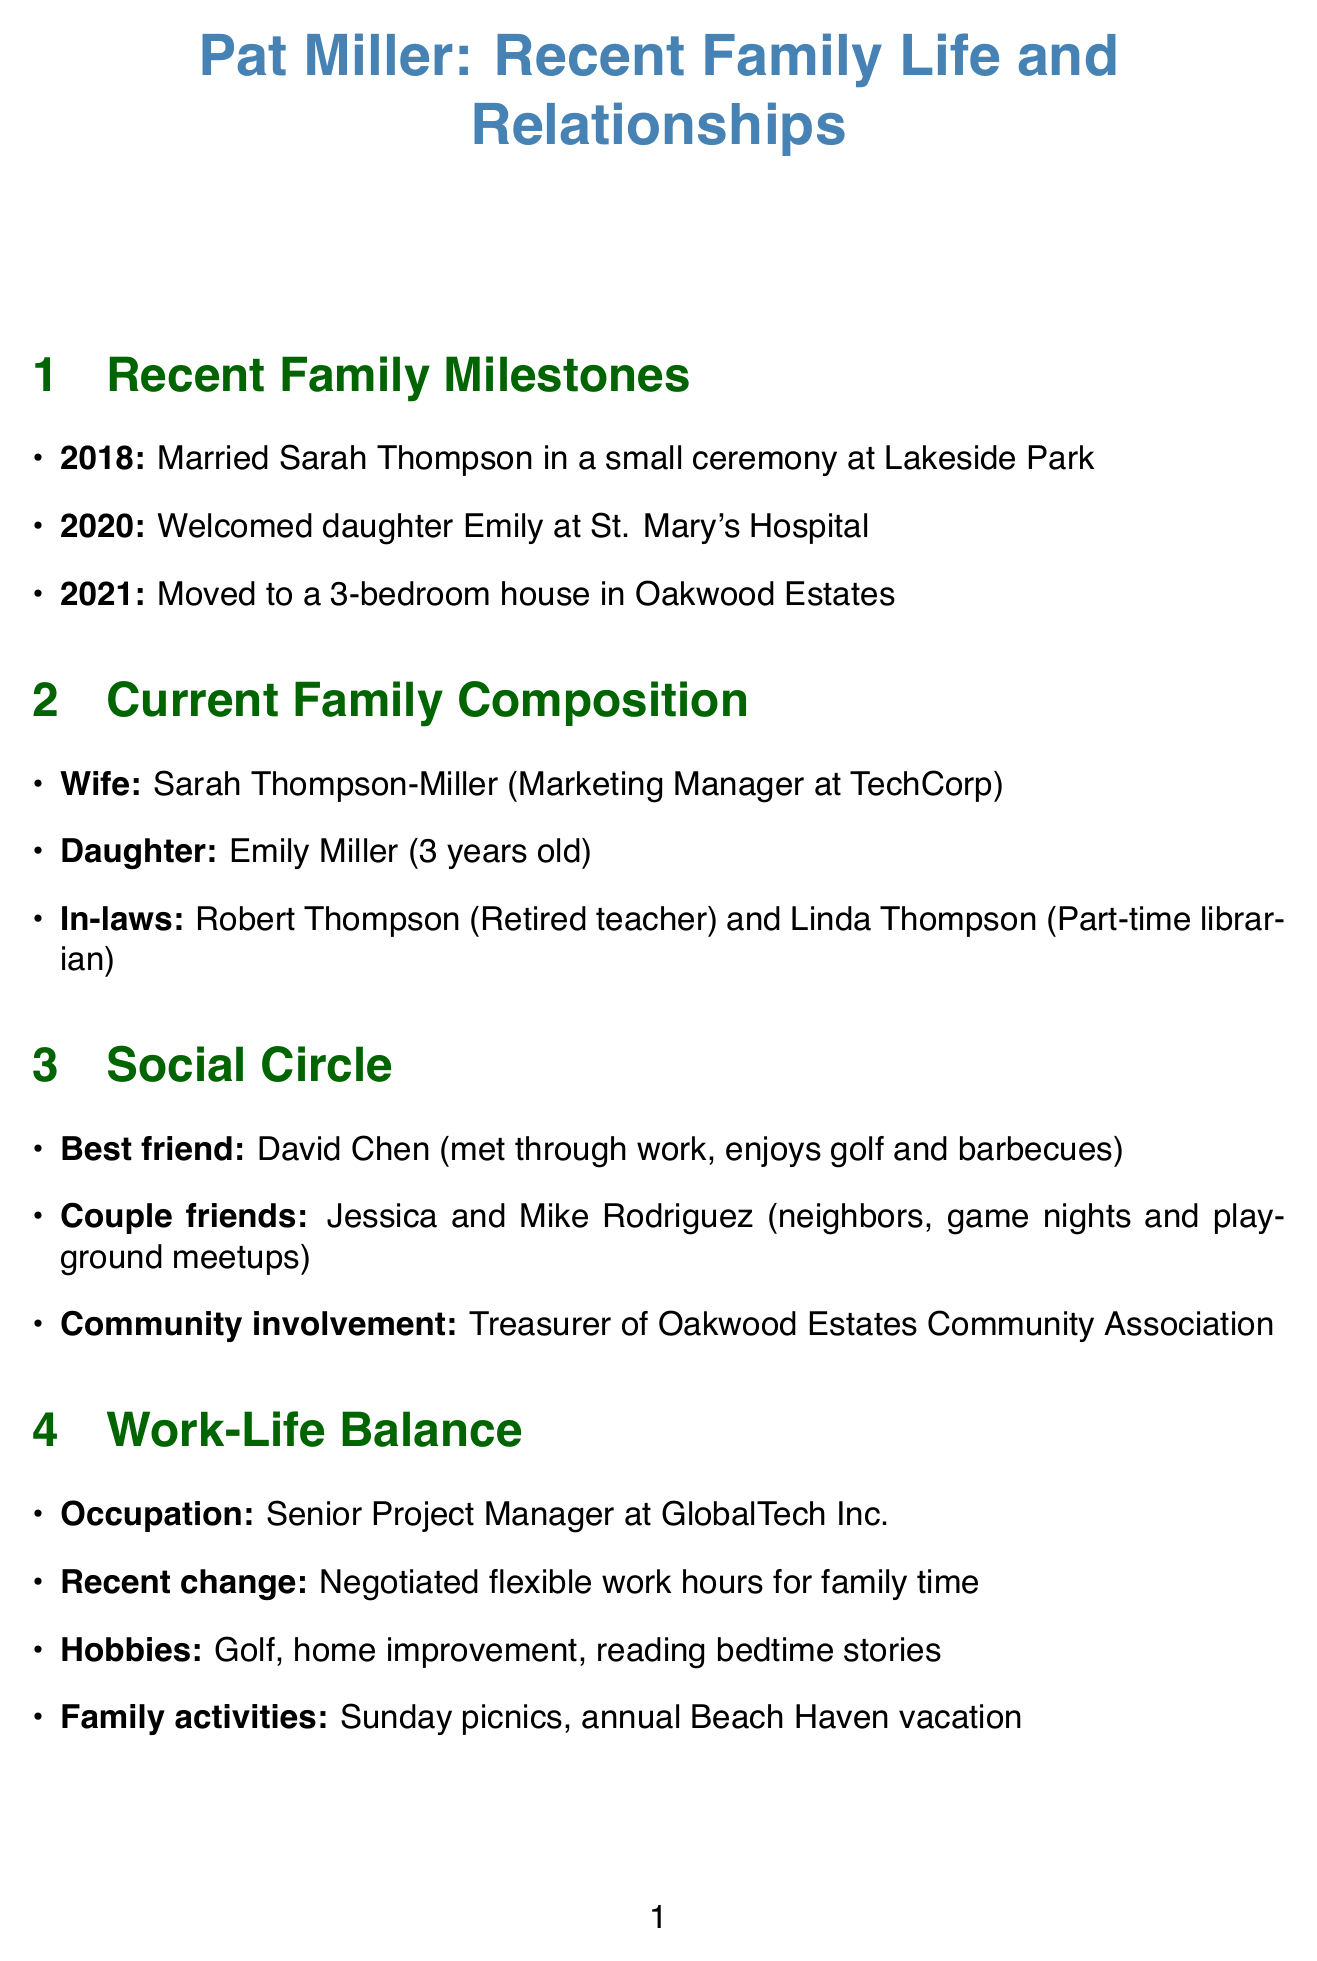What year did Pat marry Sarah Thompson? The document states that Pat married Sarah Thompson in 2018.
Answer: 2018 What is the name of Pat's daughter? The report mentions that Pat and Sarah's daughter is named Emily.
Answer: Emily What type of house did Pat and his family move to? The document indicates that the family moved to a 3-bedroom house in Oakwood Estates.
Answer: 3-bedroom house Who is Pat's best friend? According to the document, Pat's best friend is David Chen.
Answer: David Chen What is Pat's occupation? The report specifies that Pat is a Senior Project Manager at GlobalTech Inc.
Answer: Senior Project Manager What recent change did Pat make regarding his work? The document mentions that Pat negotiated flexible work hours to spend more time with family.
Answer: Flexible work hours How old is Emily? The document states that Emily is 3 years old.
Answer: 3 years old What is one of Pat's hobbies? The report lists several hobbies, one of which is weekend golf with friends.
Answer: Weekend golf What community role does Pat serve in Oakwood Estates? The document states that Pat serves as treasurer of the Oakwood Estates Community Association.
Answer: Treasurer 